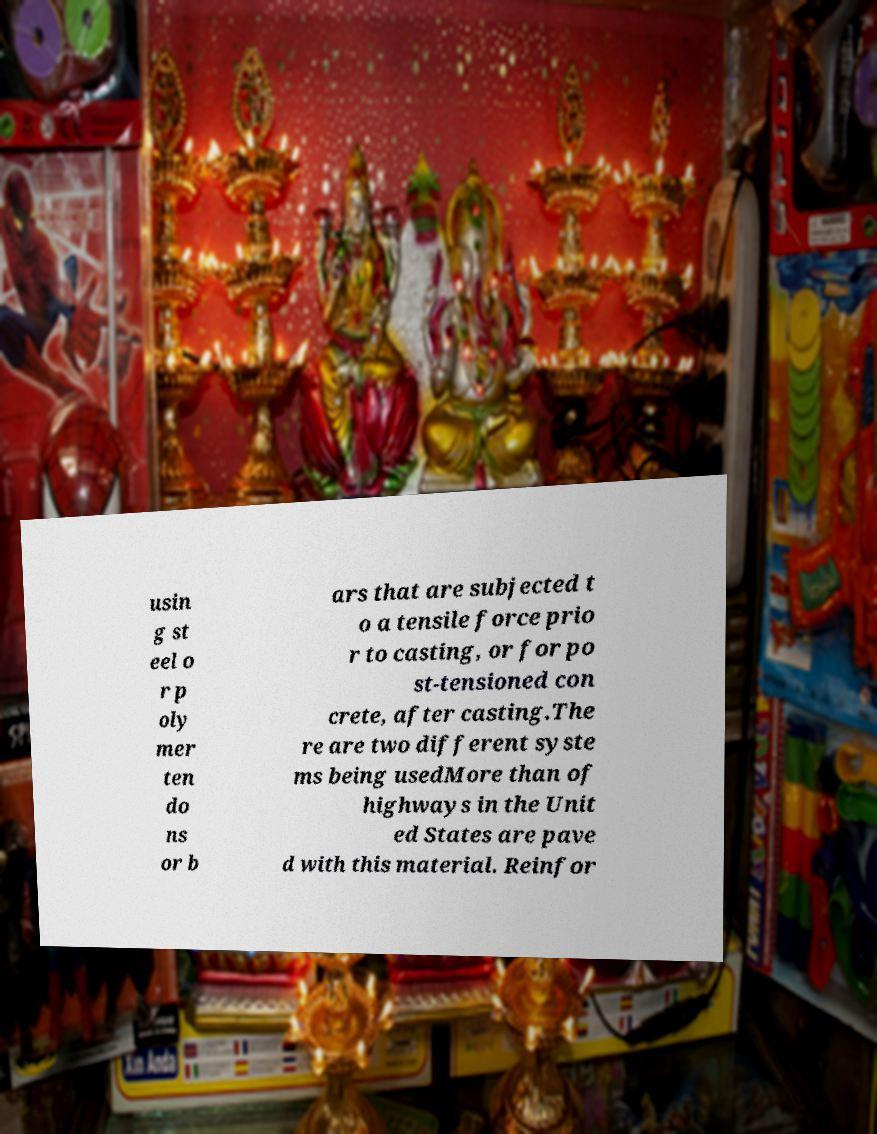Can you read and provide the text displayed in the image?This photo seems to have some interesting text. Can you extract and type it out for me? usin g st eel o r p oly mer ten do ns or b ars that are subjected t o a tensile force prio r to casting, or for po st-tensioned con crete, after casting.The re are two different syste ms being usedMore than of highways in the Unit ed States are pave d with this material. Reinfor 